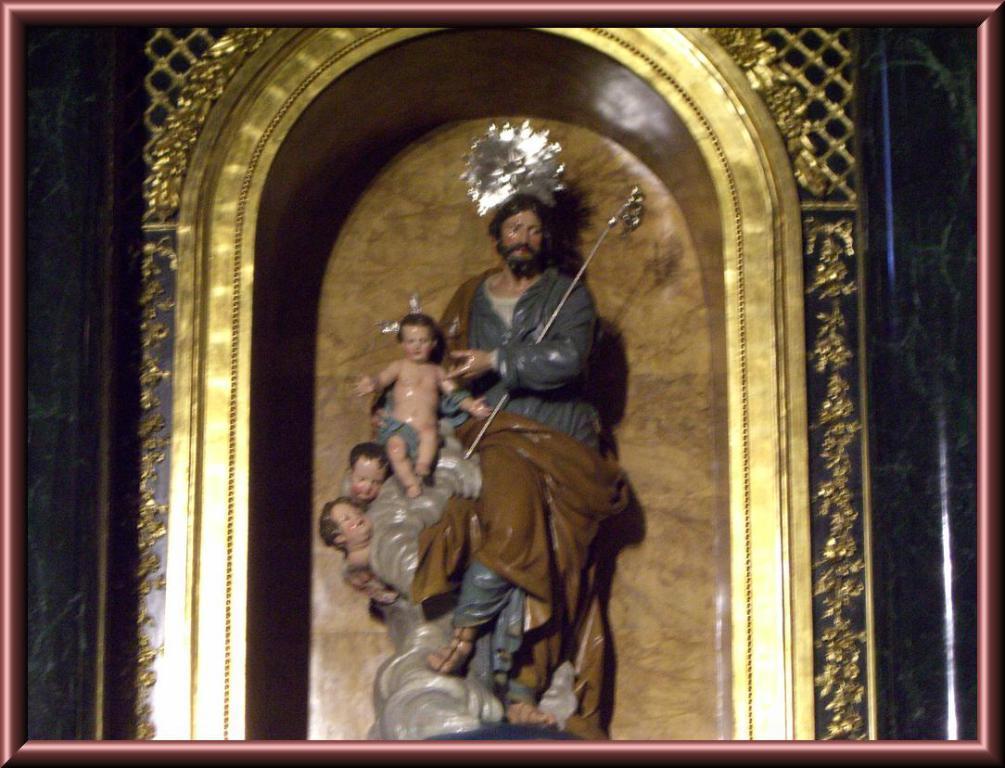In one or two sentences, can you explain what this image depicts? In this image I can see the statues of people which are in brown, grey and ash color. I can see one person with the weapon. And there is a gold color background. 